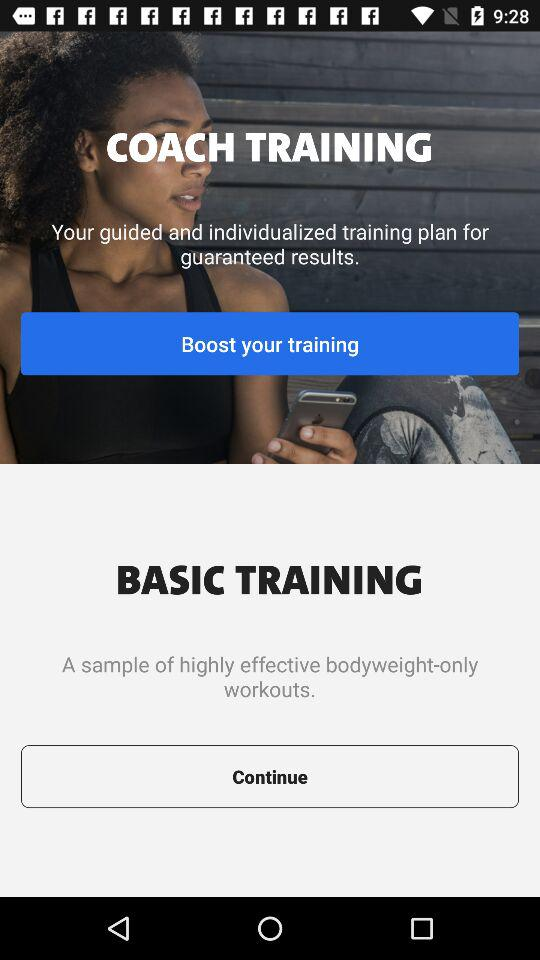How many training plans are available?
Answer the question using a single word or phrase. 2 